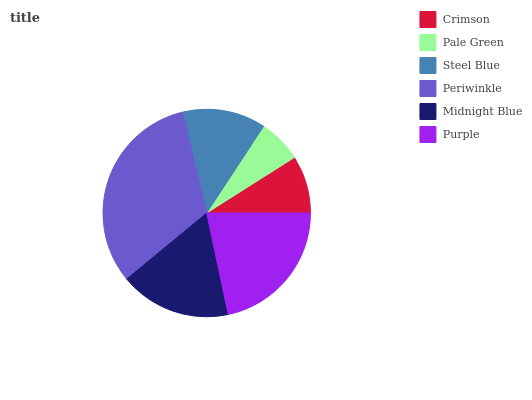Is Pale Green the minimum?
Answer yes or no. Yes. Is Periwinkle the maximum?
Answer yes or no. Yes. Is Steel Blue the minimum?
Answer yes or no. No. Is Steel Blue the maximum?
Answer yes or no. No. Is Steel Blue greater than Pale Green?
Answer yes or no. Yes. Is Pale Green less than Steel Blue?
Answer yes or no. Yes. Is Pale Green greater than Steel Blue?
Answer yes or no. No. Is Steel Blue less than Pale Green?
Answer yes or no. No. Is Midnight Blue the high median?
Answer yes or no. Yes. Is Steel Blue the low median?
Answer yes or no. Yes. Is Steel Blue the high median?
Answer yes or no. No. Is Purple the low median?
Answer yes or no. No. 